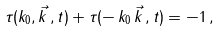Convert formula to latex. <formula><loc_0><loc_0><loc_500><loc_500>\tau ( k _ { 0 } , \vec { k } \, , t ) + \tau ( - \, k _ { 0 } \, \vec { k } \, , t ) = - 1 \, ,</formula> 